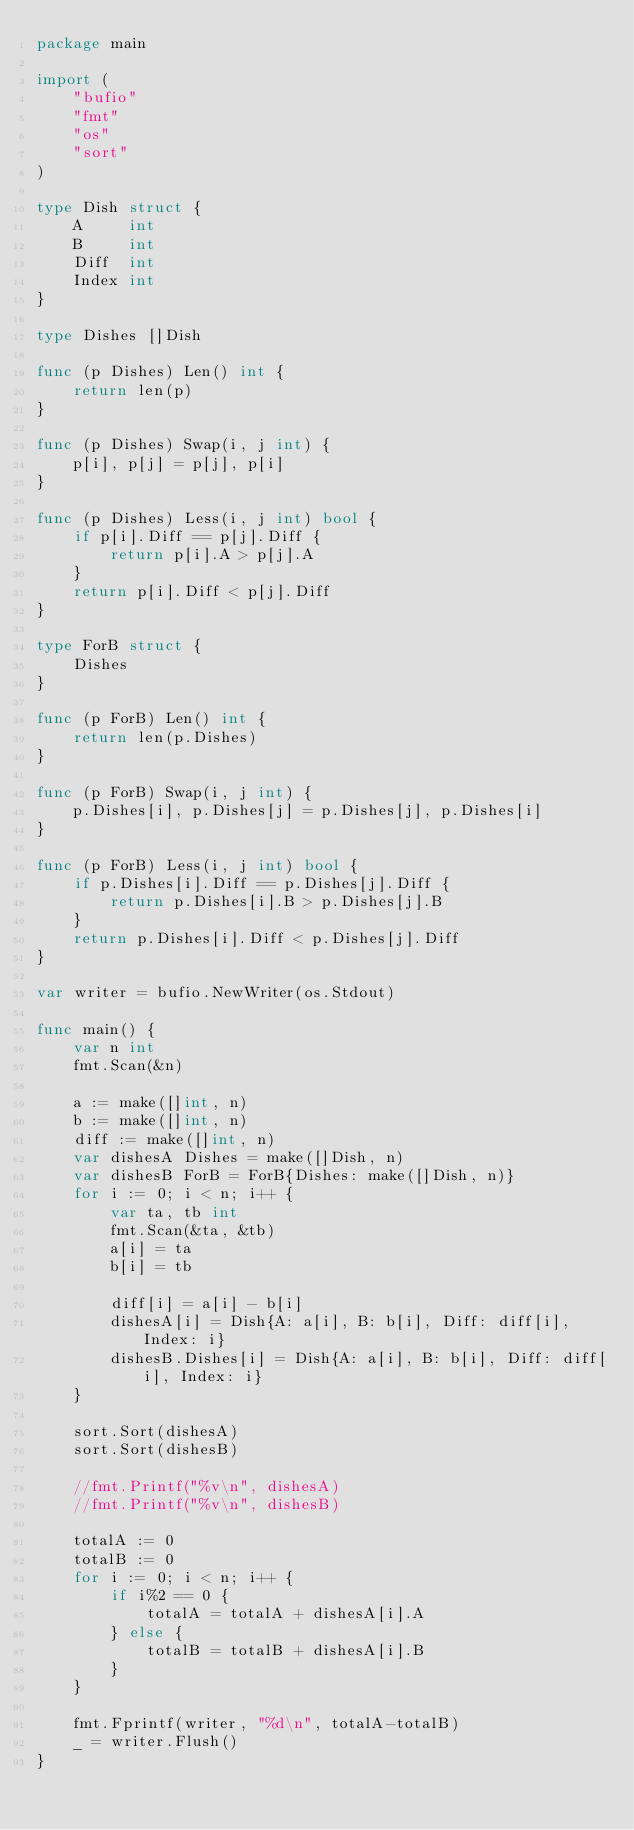<code> <loc_0><loc_0><loc_500><loc_500><_Go_>package main

import (
	"bufio"
	"fmt"
	"os"
	"sort"
)

type Dish struct {
	A     int
	B     int
	Diff  int
	Index int
}

type Dishes []Dish

func (p Dishes) Len() int {
	return len(p)
}

func (p Dishes) Swap(i, j int) {
	p[i], p[j] = p[j], p[i]
}

func (p Dishes) Less(i, j int) bool {
	if p[i].Diff == p[j].Diff {
		return p[i].A > p[j].A
	}
	return p[i].Diff < p[j].Diff
}

type ForB struct {
	Dishes
}

func (p ForB) Len() int {
	return len(p.Dishes)
}

func (p ForB) Swap(i, j int) {
	p.Dishes[i], p.Dishes[j] = p.Dishes[j], p.Dishes[i]
}

func (p ForB) Less(i, j int) bool {
	if p.Dishes[i].Diff == p.Dishes[j].Diff {
		return p.Dishes[i].B > p.Dishes[j].B
	}
	return p.Dishes[i].Diff < p.Dishes[j].Diff
}

var writer = bufio.NewWriter(os.Stdout)

func main() {
	var n int
	fmt.Scan(&n)

	a := make([]int, n)
	b := make([]int, n)
	diff := make([]int, n)
	var dishesA Dishes = make([]Dish, n)
	var dishesB ForB = ForB{Dishes: make([]Dish, n)}
	for i := 0; i < n; i++ {
		var ta, tb int
		fmt.Scan(&ta, &tb)
		a[i] = ta
		b[i] = tb

		diff[i] = a[i] - b[i]
		dishesA[i] = Dish{A: a[i], B: b[i], Diff: diff[i], Index: i}
		dishesB.Dishes[i] = Dish{A: a[i], B: b[i], Diff: diff[i], Index: i}
	}

	sort.Sort(dishesA)
	sort.Sort(dishesB)

	//fmt.Printf("%v\n", dishesA)
	//fmt.Printf("%v\n", dishesB)

	totalA := 0
	totalB := 0
	for i := 0; i < n; i++ {
		if i%2 == 0 {
			totalA = totalA + dishesA[i].A
		} else {
			totalB = totalB + dishesA[i].B
		}
	}

	fmt.Fprintf(writer, "%d\n", totalA-totalB)
	_ = writer.Flush()
}
</code> 